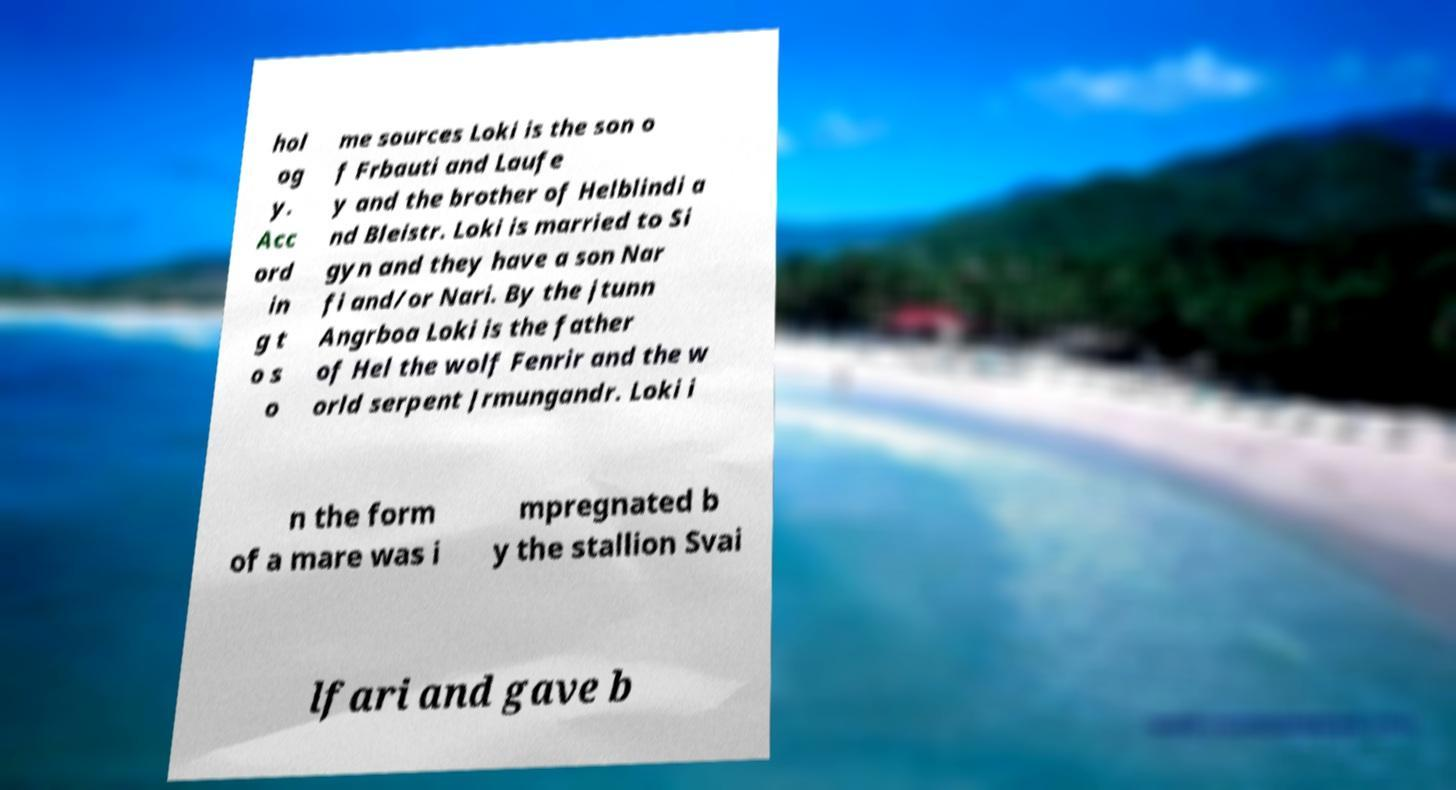What messages or text are displayed in this image? I need them in a readable, typed format. hol og y. Acc ord in g t o s o me sources Loki is the son o f Frbauti and Laufe y and the brother of Helblindi a nd Bleistr. Loki is married to Si gyn and they have a son Nar fi and/or Nari. By the jtunn Angrboa Loki is the father of Hel the wolf Fenrir and the w orld serpent Jrmungandr. Loki i n the form of a mare was i mpregnated b y the stallion Svai lfari and gave b 